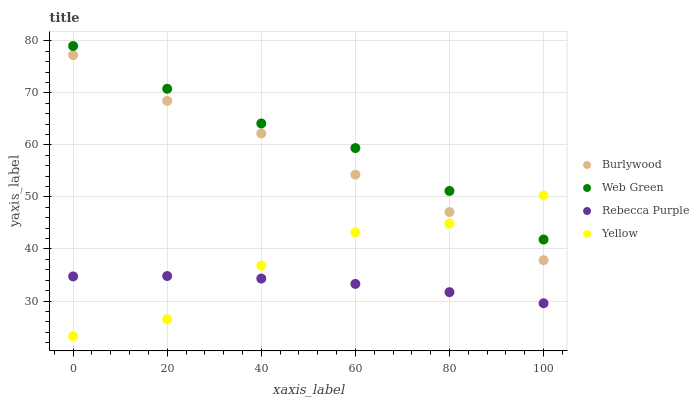Does Rebecca Purple have the minimum area under the curve?
Answer yes or no. Yes. Does Web Green have the maximum area under the curve?
Answer yes or no. Yes. Does Yellow have the minimum area under the curve?
Answer yes or no. No. Does Yellow have the maximum area under the curve?
Answer yes or no. No. Is Rebecca Purple the smoothest?
Answer yes or no. Yes. Is Yellow the roughest?
Answer yes or no. Yes. Is Yellow the smoothest?
Answer yes or no. No. Is Rebecca Purple the roughest?
Answer yes or no. No. Does Yellow have the lowest value?
Answer yes or no. Yes. Does Rebecca Purple have the lowest value?
Answer yes or no. No. Does Web Green have the highest value?
Answer yes or no. Yes. Does Yellow have the highest value?
Answer yes or no. No. Is Rebecca Purple less than Web Green?
Answer yes or no. Yes. Is Burlywood greater than Rebecca Purple?
Answer yes or no. Yes. Does Web Green intersect Yellow?
Answer yes or no. Yes. Is Web Green less than Yellow?
Answer yes or no. No. Is Web Green greater than Yellow?
Answer yes or no. No. Does Rebecca Purple intersect Web Green?
Answer yes or no. No. 